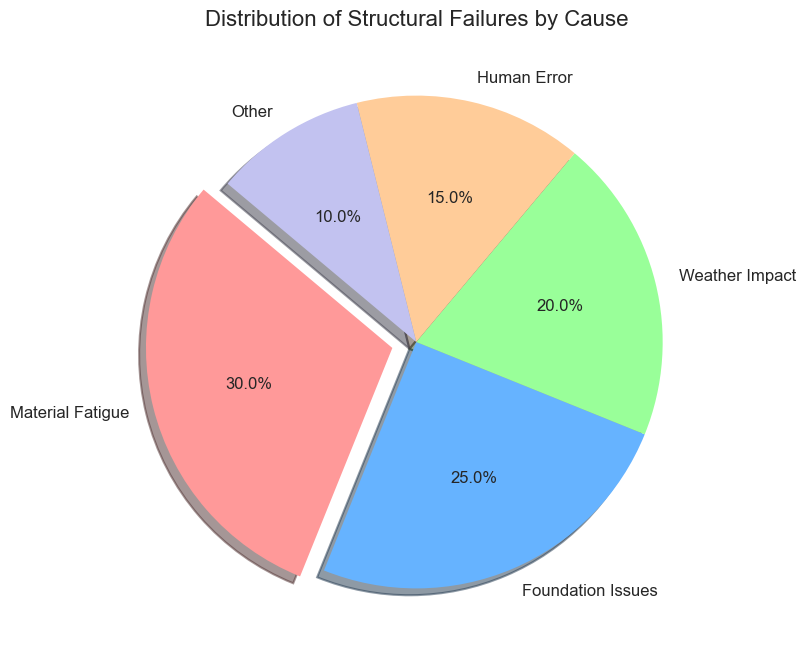Which cause of structural failure is the most common? To determine the most common cause, look at the section of the pie chart with the largest percentage. Material Fatigue is the segment that is the largest, occupying 30%.
Answer: Material Fatigue Which cause of structural failure has the smallest percentage? To find the cause with the smallest percentage, identify the smallest segment in the pie chart. The segment labeled 'Other' has the smallest part, which is 10%.
Answer: Other What is the combined percentage of structural failures due to Weather Impact and Human Error? Add the percentages for Weather Impact (20%) and Human Error (15%). This is 20 + 15, resulting in 35%.
Answer: 35% Is the percentage of structural failures due to Foundation Issues greater than that of Human Error? Compare the percentages for Foundation Issues (25%) and Human Error (15%). Since 25% is greater than 15%, the answer is yes.
Answer: Yes What is the difference in percentage points between Material Fatigue and Weather Impact? Subtract the percentage of Weather Impact (20%) from the percentage of Material Fatigue (30%). This is 30 - 20, which equals 10 percentage points.
Answer: 10 Which color represents the segment of structural failures caused by Foundation Issues? Identify the color of the segment labeled 'Foundation Issues'. It is the second segment, colored in blue.
Answer: Blue How many causes have a percentage of structural failures less than 20%? Identify segments with percentages less than 20%. These are Human Error (15%) and Other (10%), making a total of 2 causes.
Answer: 2 By how much does the percentage of Material Fatigue exceed that of Other causes? Subtract the percentage of Other causes (10%) from Material Fatigue (30%). This is 30 - 10, resulting in 20%.
Answer: 20% What is the percentage contribution of causes not related to Material Fatigue? Subtract the percentage of Material Fatigue (30%) from the total 100%. This is 100 - 30, resulting in 70%.
Answer: 70% What is the total percentage of failures attributed to Material Fatigue and Foundation Issues? Add the percentages of Material Fatigue (30%) and Foundation Issues (25%). This is 30 + 25, resulting in 55%.
Answer: 55% 